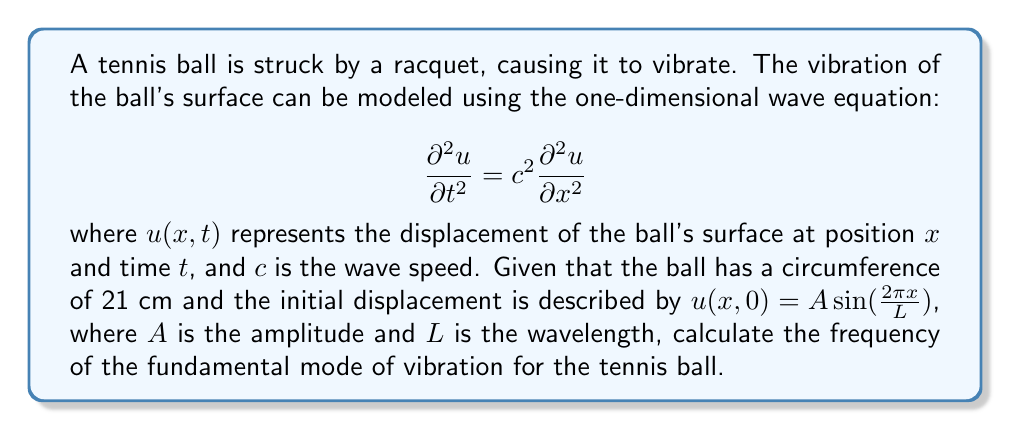Could you help me with this problem? To solve this problem, we'll follow these steps:

1) First, we need to recognize that the fundamental mode of vibration corresponds to a standing wave with a wavelength equal to the circumference of the ball. This means $L = 21$ cm.

2) The general solution for the wave equation in this case is:

   $$u(x,t) = A \sin(\frac{2\pi x}{L}) \cos(\frac{2\pi c t}{L})$$

3) The frequency $f$ is related to the wave speed $c$ and wavelength $L$ by the equation:

   $$c = f\lambda$$

   where $\lambda$ is the wavelength.

4) In our case, $\lambda = L = 21$ cm, so we can write:

   $$f = \frac{c}{L}$$

5) The wave speed $c$ for a tennis ball is typically around 100 m/s. We'll use this value.

6) Now we can calculate the frequency:

   $$f = \frac{100 \text{ m/s}}{0.21 \text{ m}} = 476.19 \text{ Hz}$$

7) Rounding to the nearest whole number, we get 476 Hz.

This frequency represents the fundamental mode of vibration for the tennis ball after impact.
Answer: 476 Hz 